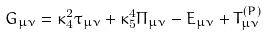Convert formula to latex. <formula><loc_0><loc_0><loc_500><loc_500>G _ { \mu \nu } = \kappa _ { 4 } ^ { 2 } \tau _ { \mu \nu } + \kappa _ { 5 } ^ { 4 } \Pi _ { \mu \nu } - E _ { \mu \nu } + T _ { \mu \nu } ^ { ( P ) }</formula> 